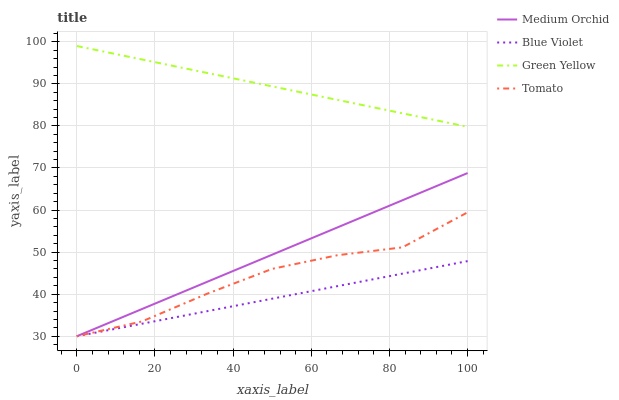Does Blue Violet have the minimum area under the curve?
Answer yes or no. Yes. Does Green Yellow have the maximum area under the curve?
Answer yes or no. Yes. Does Medium Orchid have the minimum area under the curve?
Answer yes or no. No. Does Medium Orchid have the maximum area under the curve?
Answer yes or no. No. Is Blue Violet the smoothest?
Answer yes or no. Yes. Is Tomato the roughest?
Answer yes or no. Yes. Is Green Yellow the smoothest?
Answer yes or no. No. Is Green Yellow the roughest?
Answer yes or no. No. Does Tomato have the lowest value?
Answer yes or no. Yes. Does Green Yellow have the lowest value?
Answer yes or no. No. Does Green Yellow have the highest value?
Answer yes or no. Yes. Does Medium Orchid have the highest value?
Answer yes or no. No. Is Tomato less than Green Yellow?
Answer yes or no. Yes. Is Green Yellow greater than Tomato?
Answer yes or no. Yes. Does Medium Orchid intersect Tomato?
Answer yes or no. Yes. Is Medium Orchid less than Tomato?
Answer yes or no. No. Is Medium Orchid greater than Tomato?
Answer yes or no. No. Does Tomato intersect Green Yellow?
Answer yes or no. No. 